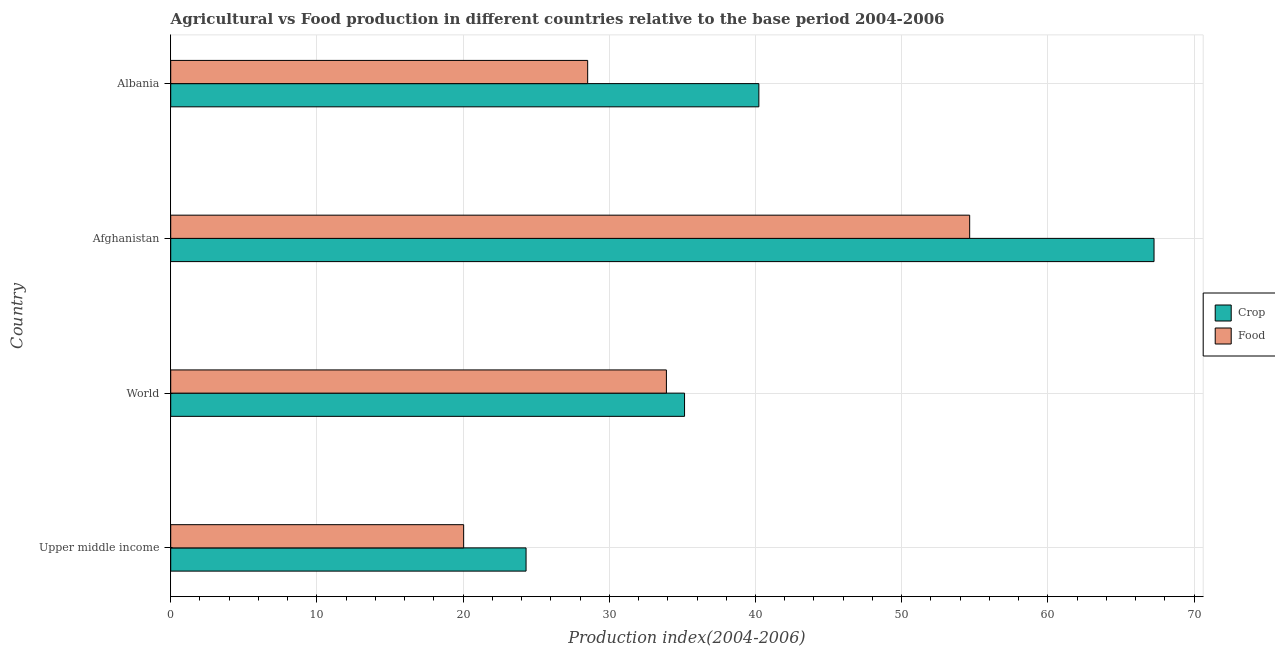How many bars are there on the 2nd tick from the top?
Make the answer very short. 2. What is the label of the 1st group of bars from the top?
Give a very brief answer. Albania. In how many cases, is the number of bars for a given country not equal to the number of legend labels?
Keep it short and to the point. 0. What is the food production index in Albania?
Offer a very short reply. 28.52. Across all countries, what is the maximum food production index?
Keep it short and to the point. 54.65. Across all countries, what is the minimum food production index?
Keep it short and to the point. 20.04. In which country was the food production index maximum?
Give a very brief answer. Afghanistan. In which country was the crop production index minimum?
Your response must be concise. Upper middle income. What is the total food production index in the graph?
Make the answer very short. 137.11. What is the difference between the crop production index in Afghanistan and that in Upper middle income?
Provide a succinct answer. 42.95. What is the difference between the food production index in Upper middle income and the crop production index in Afghanistan?
Make the answer very short. -47.22. What is the average food production index per country?
Your answer should be very brief. 34.28. What is the difference between the crop production index and food production index in Afghanistan?
Ensure brevity in your answer.  12.61. In how many countries, is the food production index greater than 18 ?
Ensure brevity in your answer.  4. What is the ratio of the crop production index in Upper middle income to that in World?
Ensure brevity in your answer.  0.69. Is the difference between the food production index in Afghanistan and Upper middle income greater than the difference between the crop production index in Afghanistan and Upper middle income?
Offer a very short reply. No. What is the difference between the highest and the second highest crop production index?
Your answer should be very brief. 27.03. What is the difference between the highest and the lowest crop production index?
Offer a terse response. 42.95. Is the sum of the crop production index in Albania and Upper middle income greater than the maximum food production index across all countries?
Ensure brevity in your answer.  Yes. What does the 1st bar from the top in Afghanistan represents?
Offer a very short reply. Food. What does the 2nd bar from the bottom in Upper middle income represents?
Provide a succinct answer. Food. Are the values on the major ticks of X-axis written in scientific E-notation?
Ensure brevity in your answer.  No. Does the graph contain grids?
Your answer should be very brief. Yes. Where does the legend appear in the graph?
Provide a succinct answer. Center right. How are the legend labels stacked?
Give a very brief answer. Vertical. What is the title of the graph?
Your response must be concise. Agricultural vs Food production in different countries relative to the base period 2004-2006. Does "Chemicals" appear as one of the legend labels in the graph?
Offer a terse response. No. What is the label or title of the X-axis?
Give a very brief answer. Production index(2004-2006). What is the label or title of the Y-axis?
Keep it short and to the point. Country. What is the Production index(2004-2006) in Crop in Upper middle income?
Make the answer very short. 24.31. What is the Production index(2004-2006) in Food in Upper middle income?
Ensure brevity in your answer.  20.04. What is the Production index(2004-2006) in Crop in World?
Offer a very short reply. 35.15. What is the Production index(2004-2006) in Food in World?
Offer a very short reply. 33.91. What is the Production index(2004-2006) of Crop in Afghanistan?
Give a very brief answer. 67.26. What is the Production index(2004-2006) of Food in Afghanistan?
Offer a very short reply. 54.65. What is the Production index(2004-2006) of Crop in Albania?
Provide a short and direct response. 40.23. What is the Production index(2004-2006) in Food in Albania?
Give a very brief answer. 28.52. Across all countries, what is the maximum Production index(2004-2006) of Crop?
Ensure brevity in your answer.  67.26. Across all countries, what is the maximum Production index(2004-2006) of Food?
Offer a terse response. 54.65. Across all countries, what is the minimum Production index(2004-2006) of Crop?
Make the answer very short. 24.31. Across all countries, what is the minimum Production index(2004-2006) in Food?
Give a very brief answer. 20.04. What is the total Production index(2004-2006) of Crop in the graph?
Ensure brevity in your answer.  166.94. What is the total Production index(2004-2006) of Food in the graph?
Ensure brevity in your answer.  137.11. What is the difference between the Production index(2004-2006) of Crop in Upper middle income and that in World?
Give a very brief answer. -10.84. What is the difference between the Production index(2004-2006) in Food in Upper middle income and that in World?
Provide a short and direct response. -13.87. What is the difference between the Production index(2004-2006) of Crop in Upper middle income and that in Afghanistan?
Ensure brevity in your answer.  -42.95. What is the difference between the Production index(2004-2006) in Food in Upper middle income and that in Afghanistan?
Your answer should be very brief. -34.61. What is the difference between the Production index(2004-2006) in Crop in Upper middle income and that in Albania?
Make the answer very short. -15.92. What is the difference between the Production index(2004-2006) in Food in Upper middle income and that in Albania?
Ensure brevity in your answer.  -8.48. What is the difference between the Production index(2004-2006) in Crop in World and that in Afghanistan?
Make the answer very short. -32.11. What is the difference between the Production index(2004-2006) in Food in World and that in Afghanistan?
Offer a terse response. -20.74. What is the difference between the Production index(2004-2006) of Crop in World and that in Albania?
Offer a very short reply. -5.08. What is the difference between the Production index(2004-2006) in Food in World and that in Albania?
Offer a terse response. 5.39. What is the difference between the Production index(2004-2006) of Crop in Afghanistan and that in Albania?
Your response must be concise. 27.03. What is the difference between the Production index(2004-2006) of Food in Afghanistan and that in Albania?
Your response must be concise. 26.13. What is the difference between the Production index(2004-2006) of Crop in Upper middle income and the Production index(2004-2006) of Food in World?
Ensure brevity in your answer.  -9.6. What is the difference between the Production index(2004-2006) of Crop in Upper middle income and the Production index(2004-2006) of Food in Afghanistan?
Your response must be concise. -30.34. What is the difference between the Production index(2004-2006) in Crop in Upper middle income and the Production index(2004-2006) in Food in Albania?
Provide a succinct answer. -4.21. What is the difference between the Production index(2004-2006) of Crop in World and the Production index(2004-2006) of Food in Afghanistan?
Your answer should be compact. -19.5. What is the difference between the Production index(2004-2006) in Crop in World and the Production index(2004-2006) in Food in Albania?
Offer a very short reply. 6.63. What is the difference between the Production index(2004-2006) in Crop in Afghanistan and the Production index(2004-2006) in Food in Albania?
Make the answer very short. 38.74. What is the average Production index(2004-2006) in Crop per country?
Your answer should be compact. 41.74. What is the average Production index(2004-2006) in Food per country?
Keep it short and to the point. 34.28. What is the difference between the Production index(2004-2006) in Crop and Production index(2004-2006) in Food in Upper middle income?
Offer a terse response. 4.27. What is the difference between the Production index(2004-2006) of Crop and Production index(2004-2006) of Food in World?
Offer a very short reply. 1.24. What is the difference between the Production index(2004-2006) of Crop and Production index(2004-2006) of Food in Afghanistan?
Offer a terse response. 12.61. What is the difference between the Production index(2004-2006) in Crop and Production index(2004-2006) in Food in Albania?
Your response must be concise. 11.71. What is the ratio of the Production index(2004-2006) in Crop in Upper middle income to that in World?
Keep it short and to the point. 0.69. What is the ratio of the Production index(2004-2006) in Food in Upper middle income to that in World?
Your answer should be very brief. 0.59. What is the ratio of the Production index(2004-2006) of Crop in Upper middle income to that in Afghanistan?
Your answer should be very brief. 0.36. What is the ratio of the Production index(2004-2006) in Food in Upper middle income to that in Afghanistan?
Ensure brevity in your answer.  0.37. What is the ratio of the Production index(2004-2006) in Crop in Upper middle income to that in Albania?
Keep it short and to the point. 0.6. What is the ratio of the Production index(2004-2006) in Food in Upper middle income to that in Albania?
Keep it short and to the point. 0.7. What is the ratio of the Production index(2004-2006) in Crop in World to that in Afghanistan?
Give a very brief answer. 0.52. What is the ratio of the Production index(2004-2006) in Food in World to that in Afghanistan?
Make the answer very short. 0.62. What is the ratio of the Production index(2004-2006) in Crop in World to that in Albania?
Give a very brief answer. 0.87. What is the ratio of the Production index(2004-2006) of Food in World to that in Albania?
Give a very brief answer. 1.19. What is the ratio of the Production index(2004-2006) in Crop in Afghanistan to that in Albania?
Make the answer very short. 1.67. What is the ratio of the Production index(2004-2006) in Food in Afghanistan to that in Albania?
Offer a terse response. 1.92. What is the difference between the highest and the second highest Production index(2004-2006) of Crop?
Your response must be concise. 27.03. What is the difference between the highest and the second highest Production index(2004-2006) in Food?
Provide a succinct answer. 20.74. What is the difference between the highest and the lowest Production index(2004-2006) in Crop?
Your answer should be compact. 42.95. What is the difference between the highest and the lowest Production index(2004-2006) in Food?
Your answer should be compact. 34.61. 